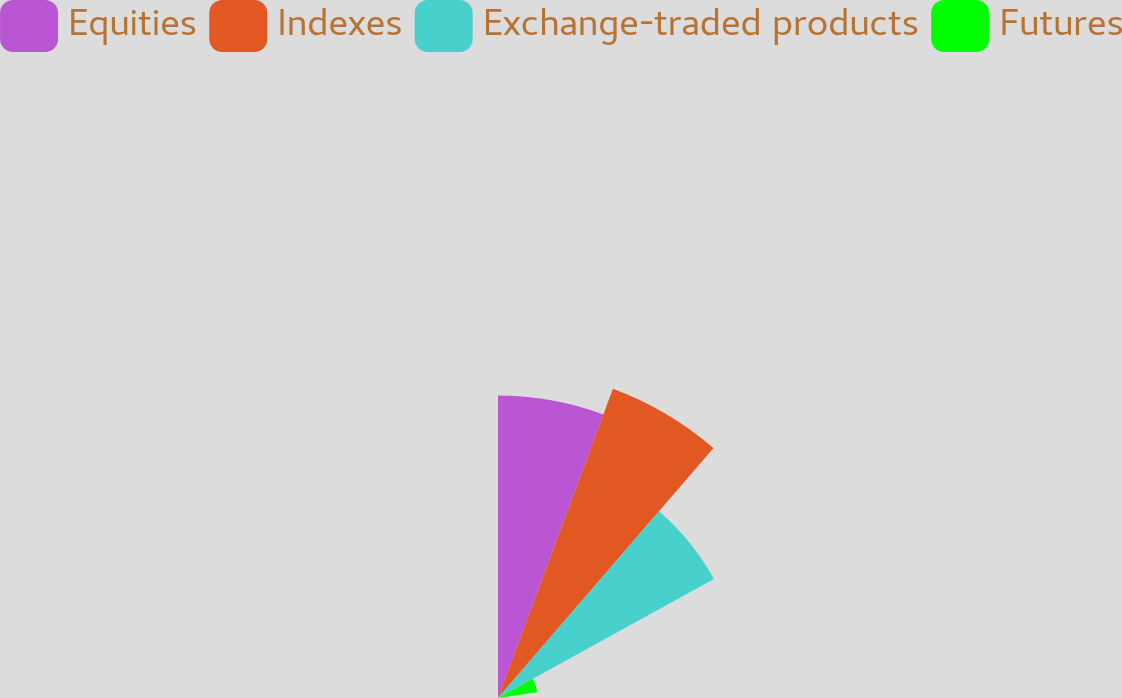Convert chart. <chart><loc_0><loc_0><loc_500><loc_500><pie_chart><fcel>Equities<fcel>Indexes<fcel>Exchange-traded products<fcel>Futures<nl><fcel>32.93%<fcel>35.92%<fcel>26.83%<fcel>4.32%<nl></chart> 